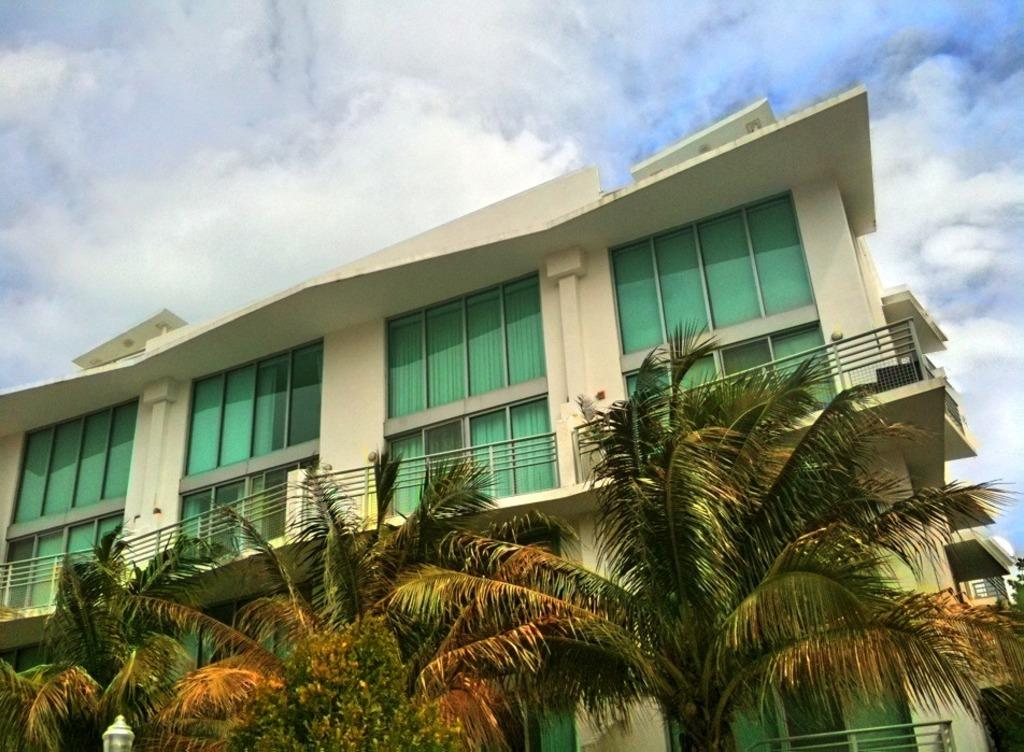What type of structure is present in the image? There is a building in the image. What feature can be seen on the building? The building has glass windows. Is there any additional architectural detail on the building? Yes, the building has a railing. What is located in front of the building? There are trees in front of the building. What can be seen at the top of the image? The sky is visible at the top of the image. How many hens are sitting on the window ledge in the image? There are no hens present in the image; it features a building with glass windows and trees in front. 